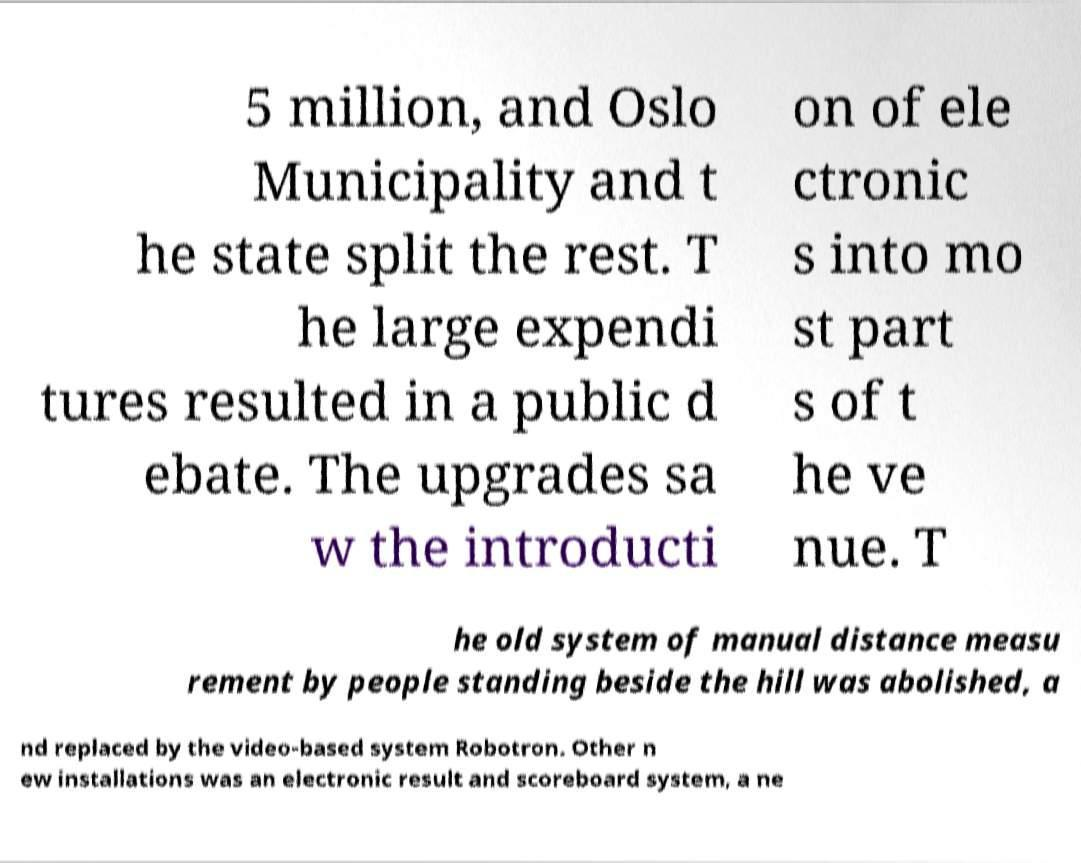Could you extract and type out the text from this image? 5 million, and Oslo Municipality and t he state split the rest. T he large expendi tures resulted in a public d ebate. The upgrades sa w the introducti on of ele ctronic s into mo st part s of t he ve nue. T he old system of manual distance measu rement by people standing beside the hill was abolished, a nd replaced by the video-based system Robotron. Other n ew installations was an electronic result and scoreboard system, a ne 